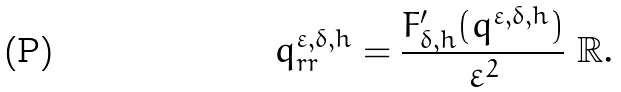Convert formula to latex. <formula><loc_0><loc_0><loc_500><loc_500>q ^ { \varepsilon , \delta , h } _ { r r } = \frac { F ^ { \prime } _ { \delta , h } ( q ^ { \varepsilon , \delta , h } ) } { \varepsilon ^ { 2 } } \ \mathbb { R } .</formula> 